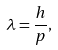Convert formula to latex. <formula><loc_0><loc_0><loc_500><loc_500>\lambda = \frac { h } { p } ,</formula> 